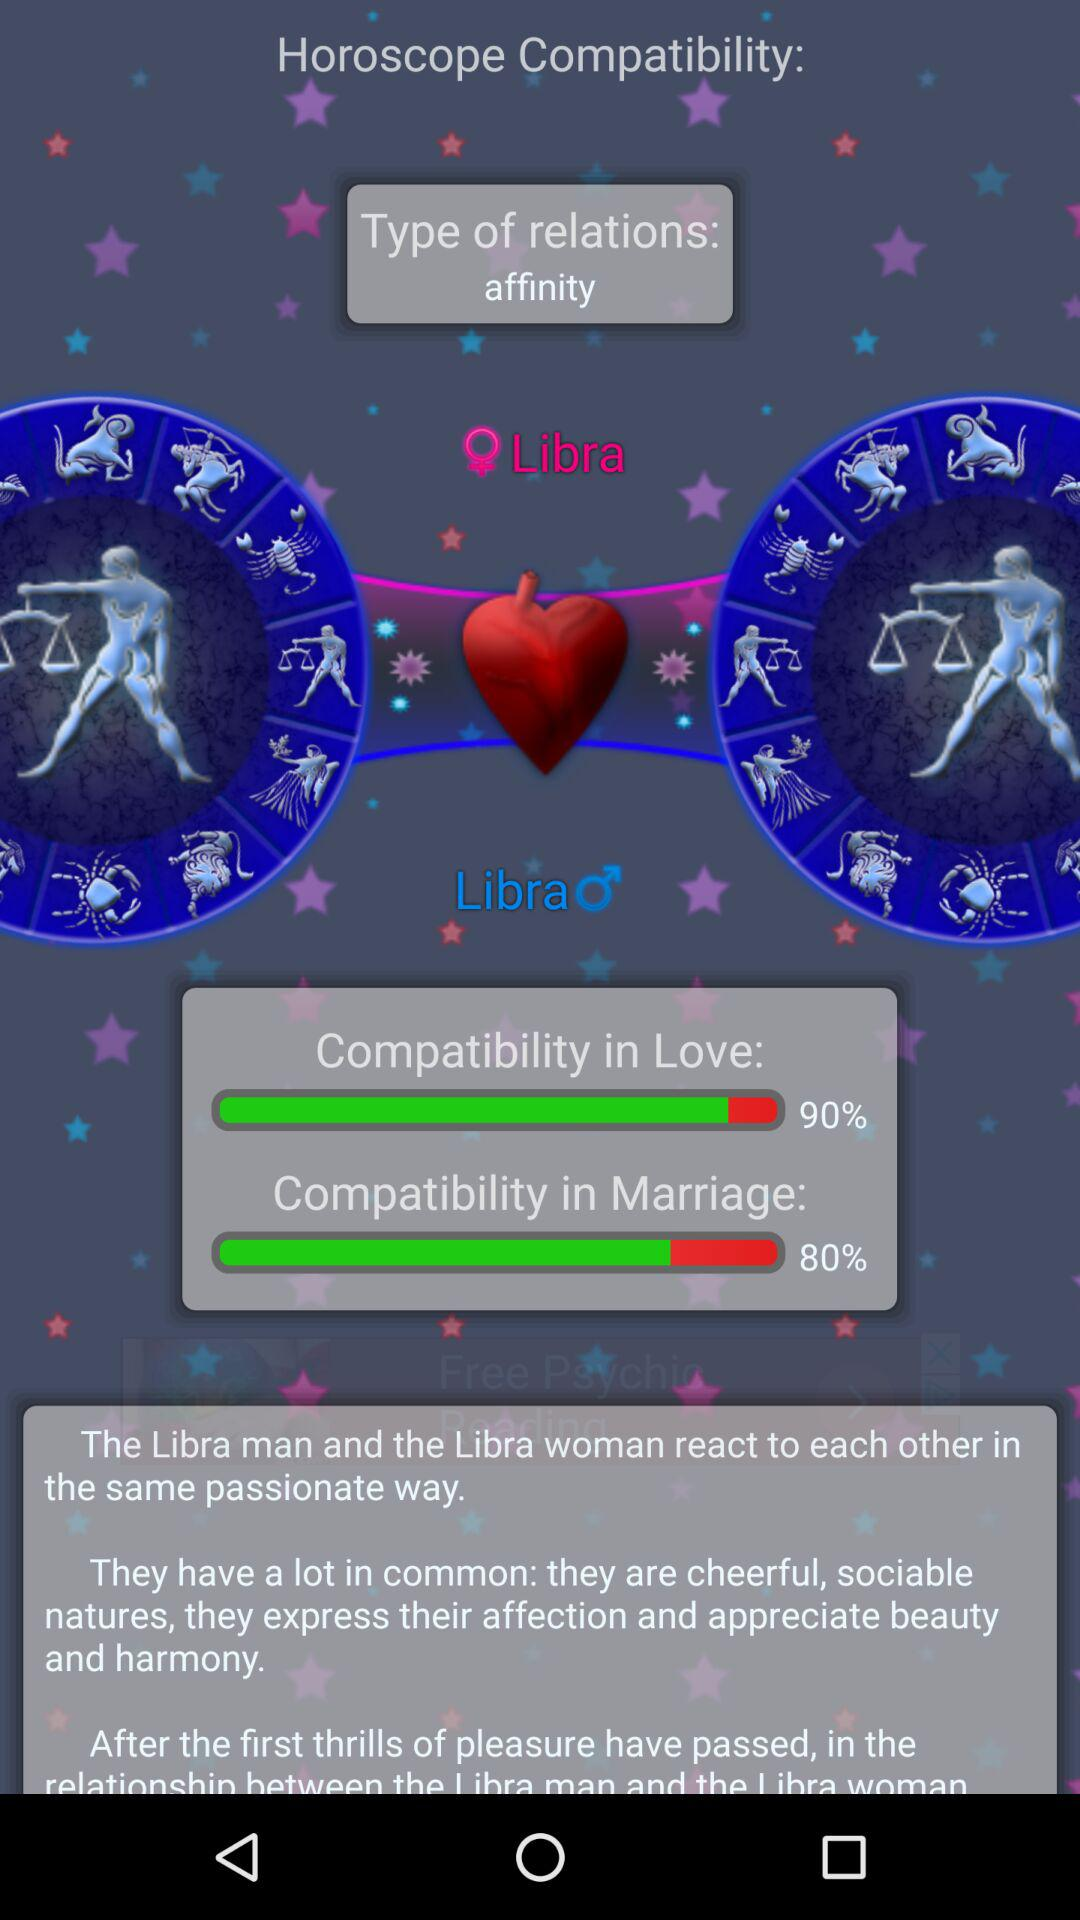What is the percentage for "Compatibility in Love"? The percentage is 90. 